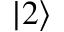<formula> <loc_0><loc_0><loc_500><loc_500>| 2 \rangle</formula> 